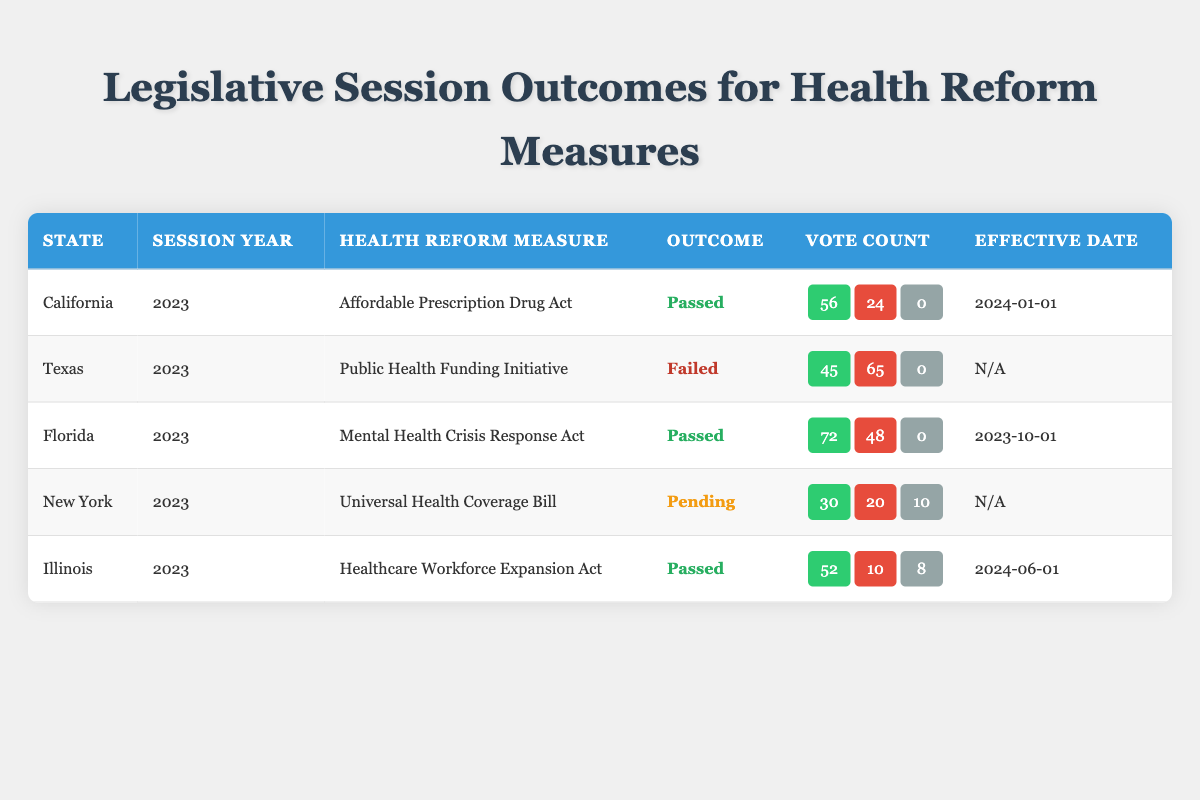What health reform measure was passed in California in 2023? The table indicates that the "Affordable Prescription Drug Act" was passed in California in the 2023 session.
Answer: Affordable Prescription Drug Act How many votes were against the "Public Health Funding Initiative" in Texas? According to the table, there were 65 votes against the "Public Health Funding Initiative" in Texas.
Answer: 65 Which state had a health reform measure that is currently pending? The table shows that New York has a health reform measure titled "Universal Health Coverage Bill" that is currently pending.
Answer: New York What is the effective date of the "Healthcare Workforce Expansion Act" in Illinois? The table states that the "Healthcare Workforce Expansion Act" in Illinois will be effective on June 1, 2024.
Answer: 2024-06-01 How many total votes were cast for and against the "Mental Health Crisis Response Act" in Florida? In Florida, the "Mental Health Crisis Response Act" had 72 votes in favor and 48 against. Adding them gives a total of 72 + 48 = 120 votes cast.
Answer: 120 Did any health reform measure in Texas pass in 2023? The information in the table clearly indicates that the "Public Health Funding Initiative" failed, which means no health reform measure passed in Texas for that year.
Answer: No What was the vote difference between in favor and against for the "Healthcare Workforce Expansion Act" in Illinois? In Illinois, the "Healthcare Workforce Expansion Act" had 52 votes in favor and 10 against. The difference can be calculated as 52 - 10 = 42.
Answer: 42 Which state had the highest number of votes in favor for a health reform measure, and what was the measure? By reviewing the table, Florida had the highest number of votes in favor with 72 for the "Mental Health Crisis Response Act."
Answer: Florida, Mental Health Crisis Response Act What percentage of the votes in favor were there for the "Universal Health Coverage Bill" in New York? The "Universal Health Coverage Bill" in New York had 30 votes in favor out of a total of (30 + 20 + 10) = 60 votes. The percentage can be calculated as (30/60) * 100 = 50%.
Answer: 50% 